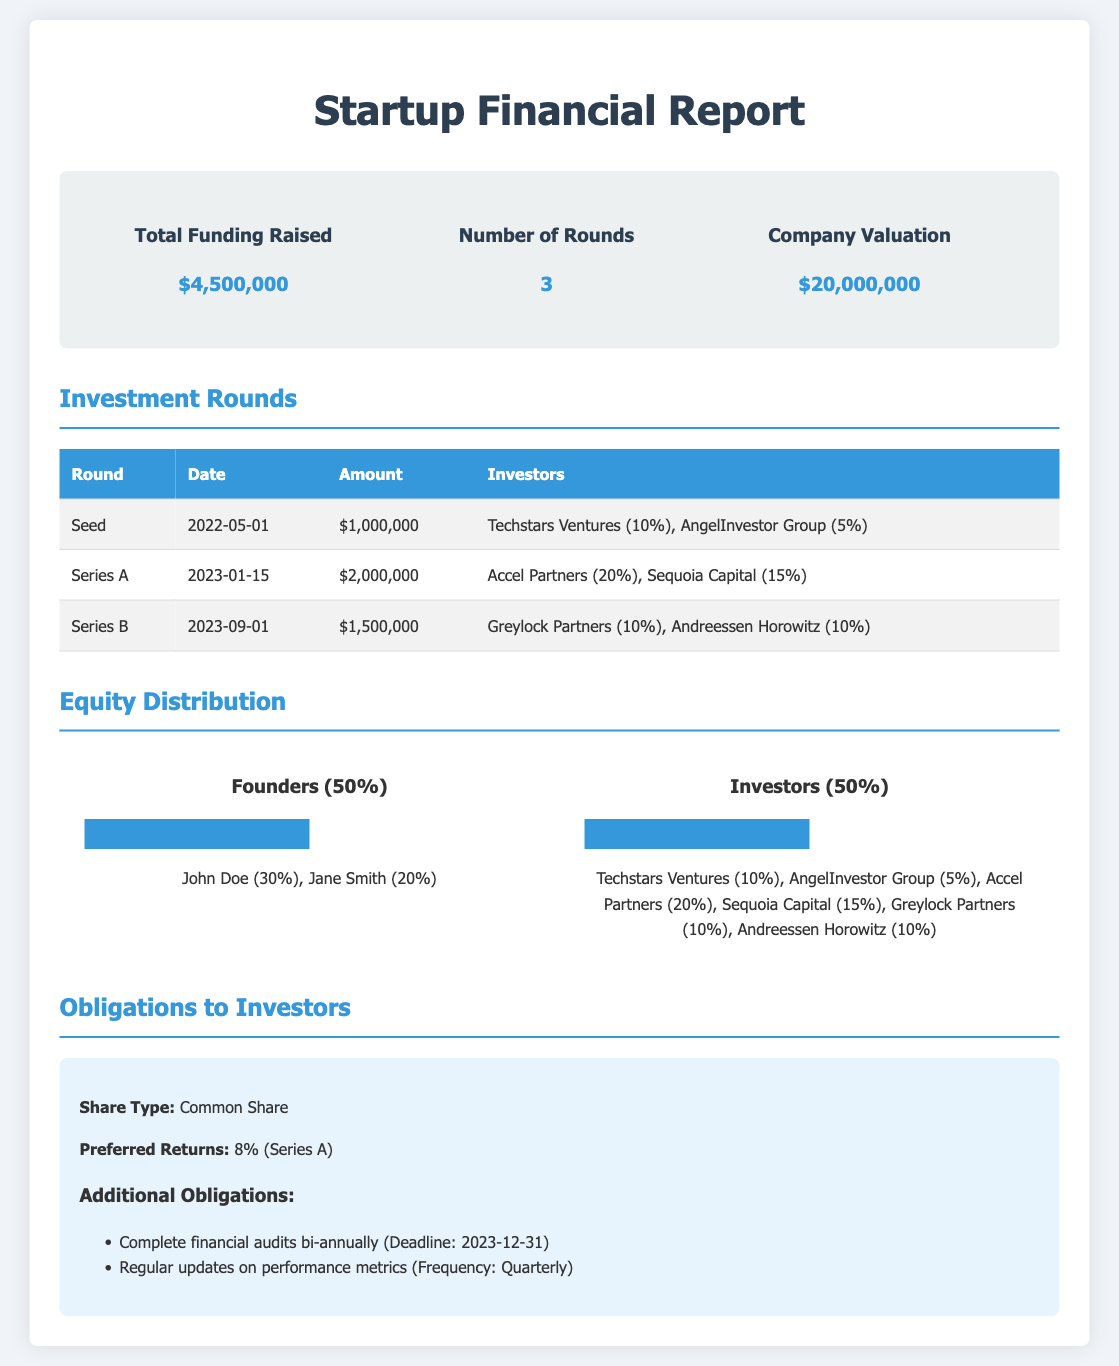What is the total funding raised? The total funding raised is explicitly mentioned in the overview section of the document.
Answer: $4,500,000 How many investment rounds were completed? The number of rounds is listed in the overview section of the document.
Answer: 3 What is the company valuation? The company valuation is provided in the overview section of the document.
Answer: $20,000,000 When did the Seed round take place? The date of the Seed round is noted in the investment rounds table.
Answer: 2022-05-01 Who invested the most in Series A? The first listed investor in Series A indicates the investor who contributed the most in that round from the document.
Answer: Accel Partners What percentage of equity do the founders hold? The equity distribution section specifies the percentage of equity held by the founders.
Answer: 50% What is the preferred return for Series A? The document details the preferred returns specifically related to Series A in the obligations section.
Answer: 8% What are the obligations related to financial audits? The document specifies the obligations regarding financial audits under the obligations section.
Answer: Bi-annually Which investors contributed to the Series B round? The investors in the Series B round are listed in the investment rounds table.
Answer: Greylock Partners, Andreessen Horowitz 